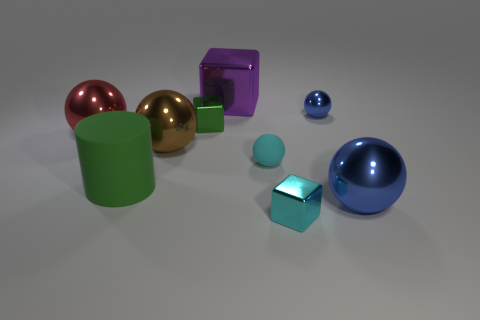Does the large green cylinder have the same material as the tiny block to the right of the purple object?
Provide a short and direct response. No. How many other tiny shiny objects are the same shape as the cyan shiny thing?
Ensure brevity in your answer.  1. There is a small cube that is the same color as the big rubber cylinder; what is its material?
Offer a very short reply. Metal. What number of large shiny objects are there?
Give a very brief answer. 4. Is the shape of the brown shiny thing the same as the large metal object that is right of the cyan matte thing?
Offer a terse response. Yes. How many things are either green rubber balls or small cyan objects in front of the green matte thing?
Give a very brief answer. 1. There is a big blue thing that is the same shape as the large red metallic object; what is its material?
Offer a terse response. Metal. There is a blue shiny thing that is in front of the red sphere; is its shape the same as the big purple object?
Provide a succinct answer. No. Is there any other thing that has the same size as the purple thing?
Make the answer very short. Yes. Is the number of blue objects that are in front of the cyan rubber ball less than the number of cyan shiny cubes in front of the large matte cylinder?
Offer a terse response. No. 